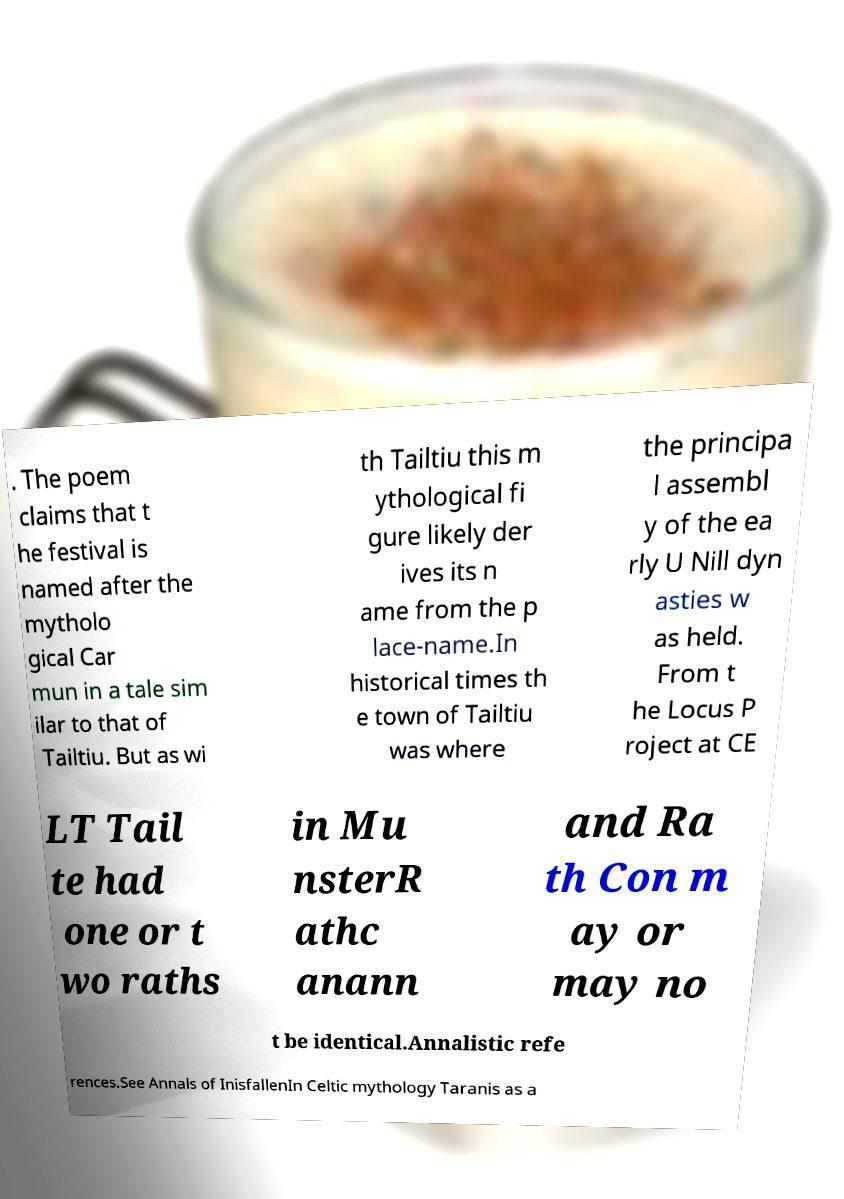Can you accurately transcribe the text from the provided image for me? . The poem claims that t he festival is named after the mytholo gical Car mun in a tale sim ilar to that of Tailtiu. But as wi th Tailtiu this m ythological fi gure likely der ives its n ame from the p lace-name.In historical times th e town of Tailtiu was where the principa l assembl y of the ea rly U Nill dyn asties w as held. From t he Locus P roject at CE LT Tail te had one or t wo raths in Mu nsterR athc anann and Ra th Con m ay or may no t be identical.Annalistic refe rences.See Annals of InisfallenIn Celtic mythology Taranis as a 